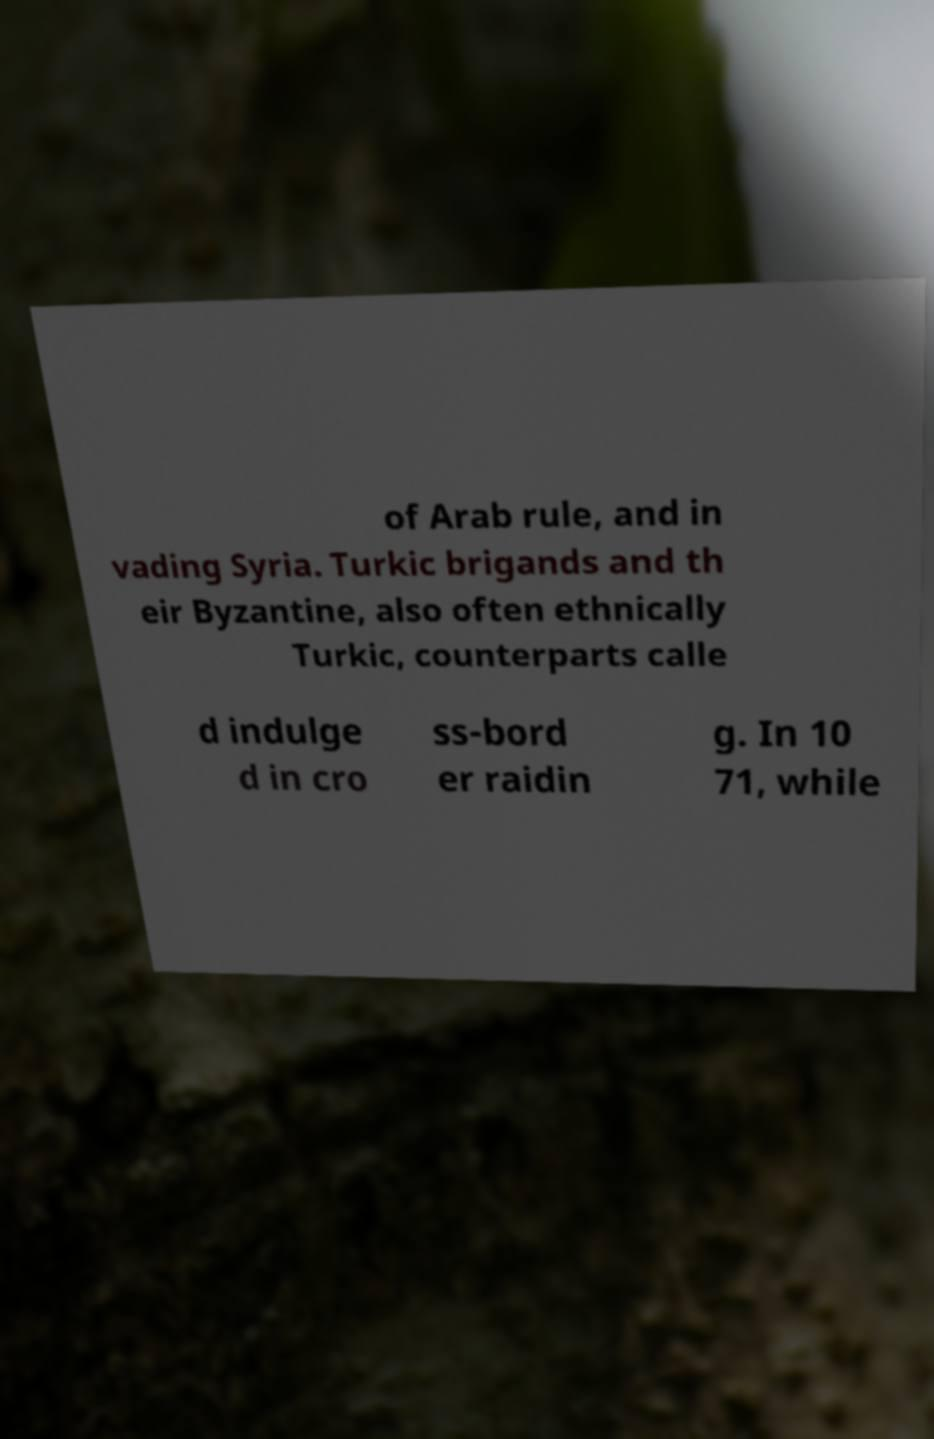I need the written content from this picture converted into text. Can you do that? of Arab rule, and in vading Syria. Turkic brigands and th eir Byzantine, also often ethnically Turkic, counterparts calle d indulge d in cro ss-bord er raidin g. In 10 71, while 